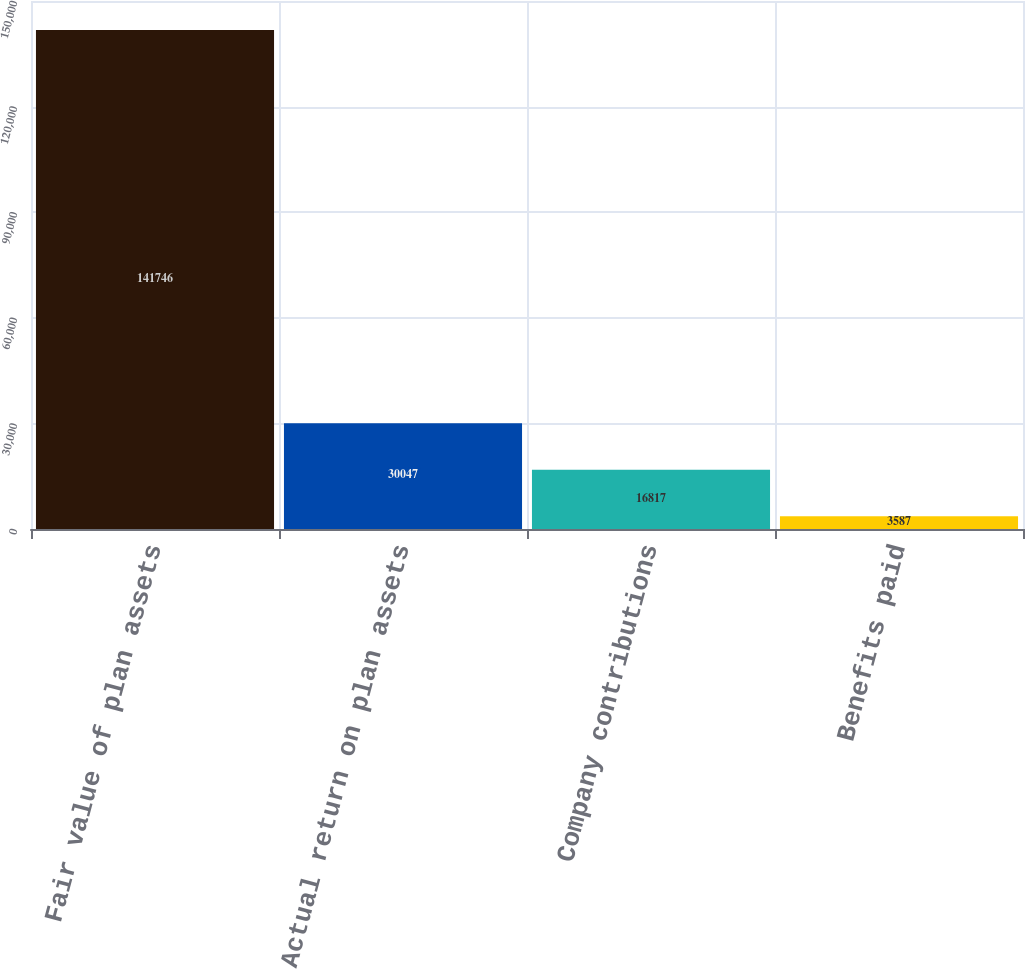<chart> <loc_0><loc_0><loc_500><loc_500><bar_chart><fcel>Fair value of plan assets<fcel>Actual return on plan assets<fcel>Company contributions<fcel>Benefits paid<nl><fcel>141746<fcel>30047<fcel>16817<fcel>3587<nl></chart> 